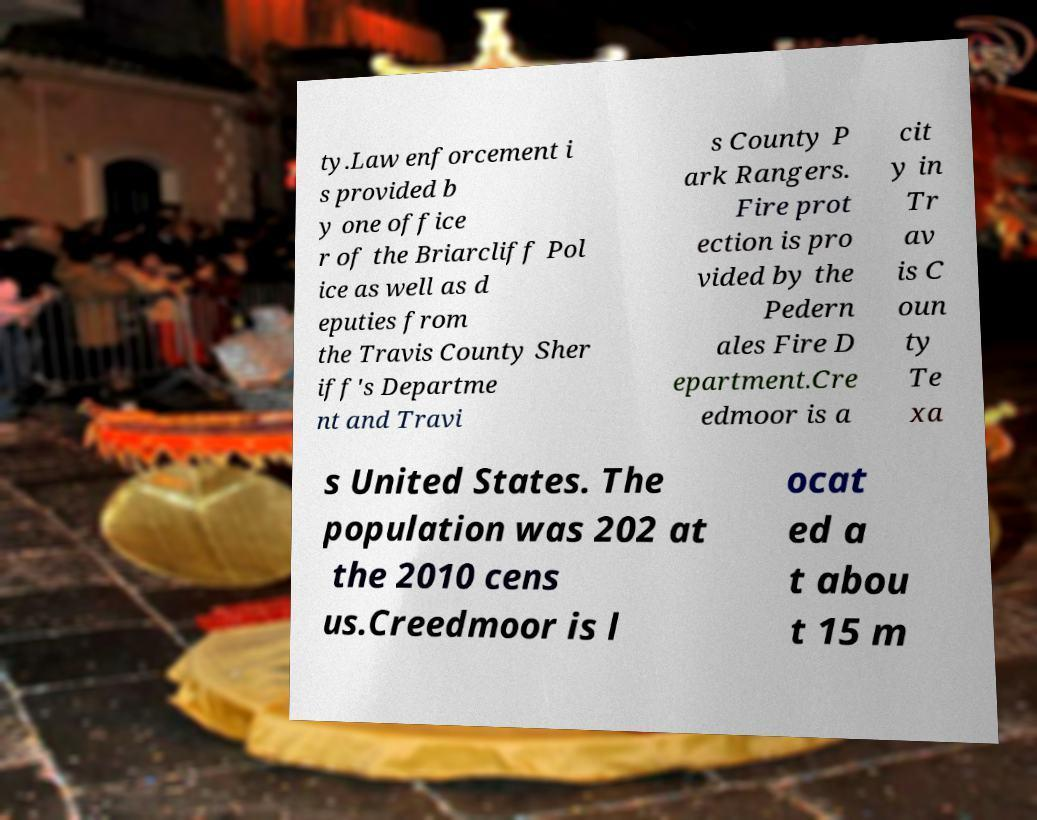Please identify and transcribe the text found in this image. ty.Law enforcement i s provided b y one office r of the Briarcliff Pol ice as well as d eputies from the Travis County Sher iff's Departme nt and Travi s County P ark Rangers. Fire prot ection is pro vided by the Pedern ales Fire D epartment.Cre edmoor is a cit y in Tr av is C oun ty Te xa s United States. The population was 202 at the 2010 cens us.Creedmoor is l ocat ed a t abou t 15 m 